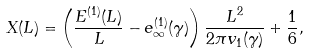Convert formula to latex. <formula><loc_0><loc_0><loc_500><loc_500>X ( L ) = \left ( \frac { E ^ { ( 1 ) } ( L ) } { L } - e _ { \infty } ^ { ( 1 ) } ( \gamma ) \right ) \frac { L ^ { 2 } } { 2 \pi v _ { 1 } ( \gamma ) } + \frac { 1 } { 6 } ,</formula> 